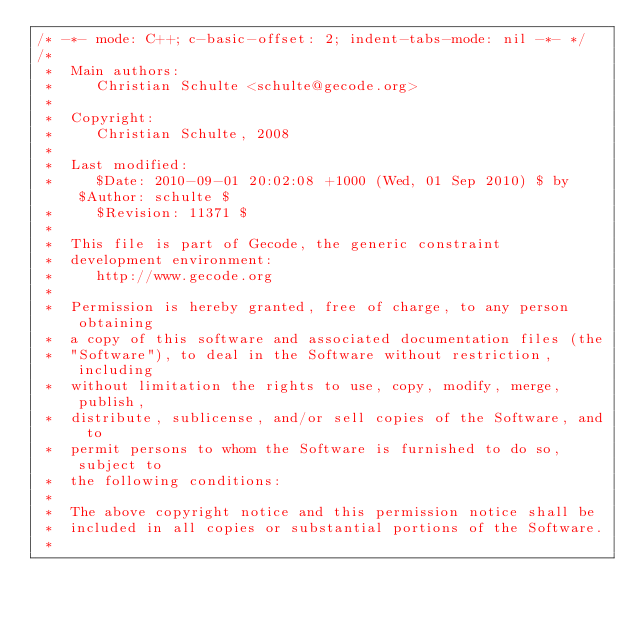<code> <loc_0><loc_0><loc_500><loc_500><_C++_>/* -*- mode: C++; c-basic-offset: 2; indent-tabs-mode: nil -*- */
/*
 *  Main authors:
 *     Christian Schulte <schulte@gecode.org>
 *
 *  Copyright:
 *     Christian Schulte, 2008
 *
 *  Last modified:
 *     $Date: 2010-09-01 20:02:08 +1000 (Wed, 01 Sep 2010) $ by $Author: schulte $
 *     $Revision: 11371 $
 *
 *  This file is part of Gecode, the generic constraint
 *  development environment:
 *     http://www.gecode.org
 *
 *  Permission is hereby granted, free of charge, to any person obtaining
 *  a copy of this software and associated documentation files (the
 *  "Software"), to deal in the Software without restriction, including
 *  without limitation the rights to use, copy, modify, merge, publish,
 *  distribute, sublicense, and/or sell copies of the Software, and to
 *  permit persons to whom the Software is furnished to do so, subject to
 *  the following conditions:
 *
 *  The above copyright notice and this permission notice shall be
 *  included in all copies or substantial portions of the Software.
 *</code> 